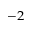<formula> <loc_0><loc_0><loc_500><loc_500>^ { - 2 }</formula> 